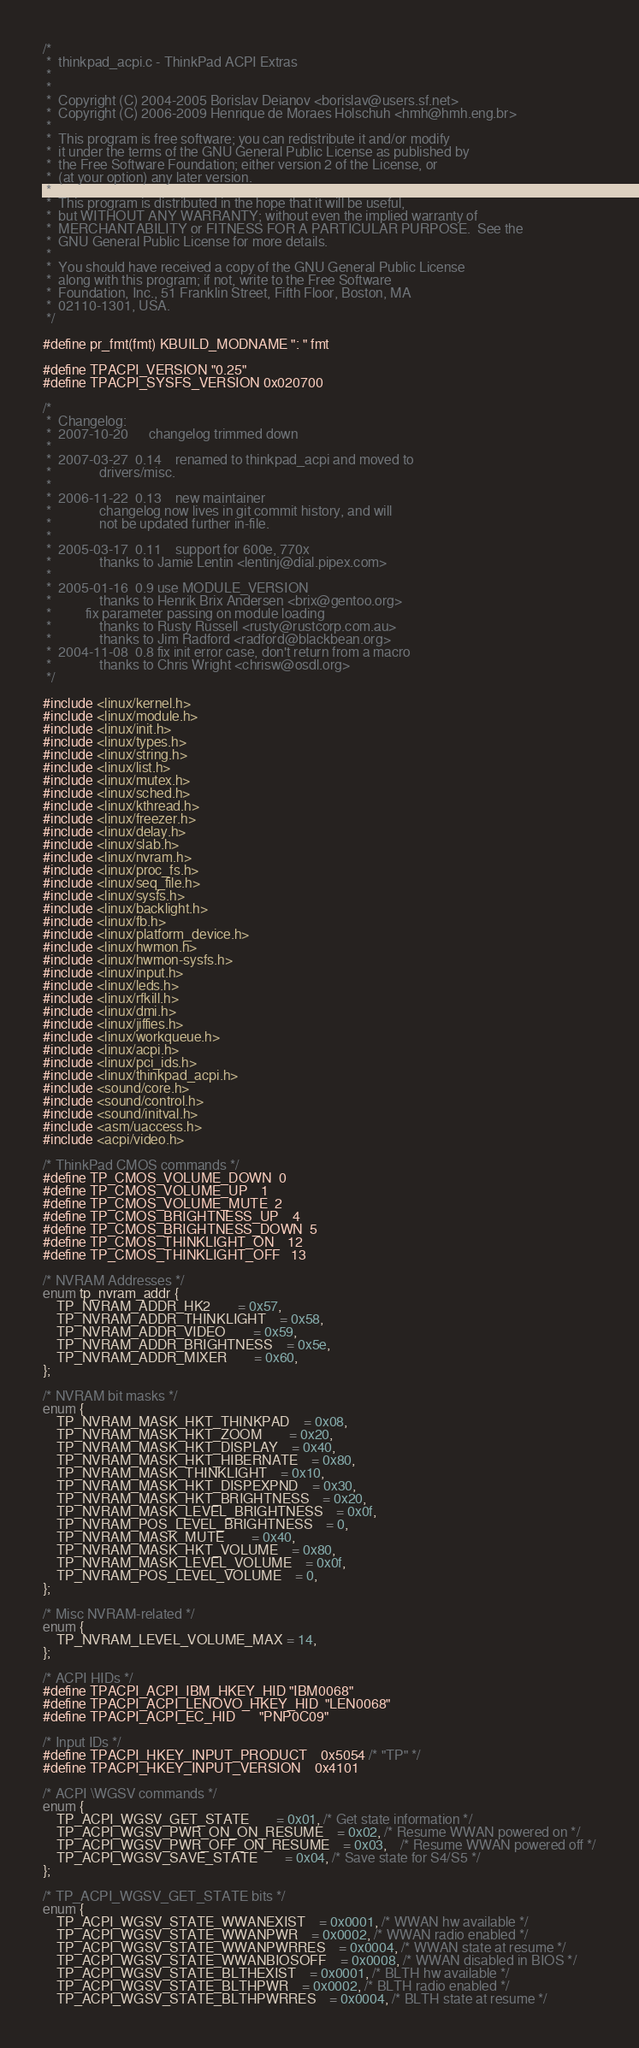<code> <loc_0><loc_0><loc_500><loc_500><_C_>/*
 *  thinkpad_acpi.c - ThinkPad ACPI Extras
 *
 *
 *  Copyright (C) 2004-2005 Borislav Deianov <borislav@users.sf.net>
 *  Copyright (C) 2006-2009 Henrique de Moraes Holschuh <hmh@hmh.eng.br>
 *
 *  This program is free software; you can redistribute it and/or modify
 *  it under the terms of the GNU General Public License as published by
 *  the Free Software Foundation; either version 2 of the License, or
 *  (at your option) any later version.
 *
 *  This program is distributed in the hope that it will be useful,
 *  but WITHOUT ANY WARRANTY; without even the implied warranty of
 *  MERCHANTABILITY or FITNESS FOR A PARTICULAR PURPOSE.  See the
 *  GNU General Public License for more details.
 *
 *  You should have received a copy of the GNU General Public License
 *  along with this program; if not, write to the Free Software
 *  Foundation, Inc., 51 Franklin Street, Fifth Floor, Boston, MA
 *  02110-1301, USA.
 */

#define pr_fmt(fmt) KBUILD_MODNAME ": " fmt

#define TPACPI_VERSION "0.25"
#define TPACPI_SYSFS_VERSION 0x020700

/*
 *  Changelog:
 *  2007-10-20		changelog trimmed down
 *
 *  2007-03-27  0.14	renamed to thinkpad_acpi and moved to
 *  			drivers/misc.
 *
 *  2006-11-22	0.13	new maintainer
 *  			changelog now lives in git commit history, and will
 *  			not be updated further in-file.
 *
 *  2005-03-17	0.11	support for 600e, 770x
 *			    thanks to Jamie Lentin <lentinj@dial.pipex.com>
 *
 *  2005-01-16	0.9	use MODULE_VERSION
 *			    thanks to Henrik Brix Andersen <brix@gentoo.org>
 *			fix parameter passing on module loading
 *			    thanks to Rusty Russell <rusty@rustcorp.com.au>
 *			    thanks to Jim Radford <radford@blackbean.org>
 *  2004-11-08	0.8	fix init error case, don't return from a macro
 *			    thanks to Chris Wright <chrisw@osdl.org>
 */

#include <linux/kernel.h>
#include <linux/module.h>
#include <linux/init.h>
#include <linux/types.h>
#include <linux/string.h>
#include <linux/list.h>
#include <linux/mutex.h>
#include <linux/sched.h>
#include <linux/kthread.h>
#include <linux/freezer.h>
#include <linux/delay.h>
#include <linux/slab.h>
#include <linux/nvram.h>
#include <linux/proc_fs.h>
#include <linux/seq_file.h>
#include <linux/sysfs.h>
#include <linux/backlight.h>
#include <linux/fb.h>
#include <linux/platform_device.h>
#include <linux/hwmon.h>
#include <linux/hwmon-sysfs.h>
#include <linux/input.h>
#include <linux/leds.h>
#include <linux/rfkill.h>
#include <linux/dmi.h>
#include <linux/jiffies.h>
#include <linux/workqueue.h>
#include <linux/acpi.h>
#include <linux/pci_ids.h>
#include <linux/thinkpad_acpi.h>
#include <sound/core.h>
#include <sound/control.h>
#include <sound/initval.h>
#include <asm/uaccess.h>
#include <acpi/video.h>

/* ThinkPad CMOS commands */
#define TP_CMOS_VOLUME_DOWN	0
#define TP_CMOS_VOLUME_UP	1
#define TP_CMOS_VOLUME_MUTE	2
#define TP_CMOS_BRIGHTNESS_UP	4
#define TP_CMOS_BRIGHTNESS_DOWN	5
#define TP_CMOS_THINKLIGHT_ON	12
#define TP_CMOS_THINKLIGHT_OFF	13

/* NVRAM Addresses */
enum tp_nvram_addr {
	TP_NVRAM_ADDR_HK2		= 0x57,
	TP_NVRAM_ADDR_THINKLIGHT	= 0x58,
	TP_NVRAM_ADDR_VIDEO		= 0x59,
	TP_NVRAM_ADDR_BRIGHTNESS	= 0x5e,
	TP_NVRAM_ADDR_MIXER		= 0x60,
};

/* NVRAM bit masks */
enum {
	TP_NVRAM_MASK_HKT_THINKPAD	= 0x08,
	TP_NVRAM_MASK_HKT_ZOOM		= 0x20,
	TP_NVRAM_MASK_HKT_DISPLAY	= 0x40,
	TP_NVRAM_MASK_HKT_HIBERNATE	= 0x80,
	TP_NVRAM_MASK_THINKLIGHT	= 0x10,
	TP_NVRAM_MASK_HKT_DISPEXPND	= 0x30,
	TP_NVRAM_MASK_HKT_BRIGHTNESS	= 0x20,
	TP_NVRAM_MASK_LEVEL_BRIGHTNESS	= 0x0f,
	TP_NVRAM_POS_LEVEL_BRIGHTNESS	= 0,
	TP_NVRAM_MASK_MUTE		= 0x40,
	TP_NVRAM_MASK_HKT_VOLUME	= 0x80,
	TP_NVRAM_MASK_LEVEL_VOLUME	= 0x0f,
	TP_NVRAM_POS_LEVEL_VOLUME	= 0,
};

/* Misc NVRAM-related */
enum {
	TP_NVRAM_LEVEL_VOLUME_MAX = 14,
};

/* ACPI HIDs */
#define TPACPI_ACPI_IBM_HKEY_HID	"IBM0068"
#define TPACPI_ACPI_LENOVO_HKEY_HID	"LEN0068"
#define TPACPI_ACPI_EC_HID		"PNP0C09"

/* Input IDs */
#define TPACPI_HKEY_INPUT_PRODUCT	0x5054 /* "TP" */
#define TPACPI_HKEY_INPUT_VERSION	0x4101

/* ACPI \WGSV commands */
enum {
	TP_ACPI_WGSV_GET_STATE		= 0x01, /* Get state information */
	TP_ACPI_WGSV_PWR_ON_ON_RESUME	= 0x02, /* Resume WWAN powered on */
	TP_ACPI_WGSV_PWR_OFF_ON_RESUME	= 0x03,	/* Resume WWAN powered off */
	TP_ACPI_WGSV_SAVE_STATE		= 0x04, /* Save state for S4/S5 */
};

/* TP_ACPI_WGSV_GET_STATE bits */
enum {
	TP_ACPI_WGSV_STATE_WWANEXIST	= 0x0001, /* WWAN hw available */
	TP_ACPI_WGSV_STATE_WWANPWR	= 0x0002, /* WWAN radio enabled */
	TP_ACPI_WGSV_STATE_WWANPWRRES	= 0x0004, /* WWAN state at resume */
	TP_ACPI_WGSV_STATE_WWANBIOSOFF	= 0x0008, /* WWAN disabled in BIOS */
	TP_ACPI_WGSV_STATE_BLTHEXIST	= 0x0001, /* BLTH hw available */
	TP_ACPI_WGSV_STATE_BLTHPWR	= 0x0002, /* BLTH radio enabled */
	TP_ACPI_WGSV_STATE_BLTHPWRRES	= 0x0004, /* BLTH state at resume */</code> 